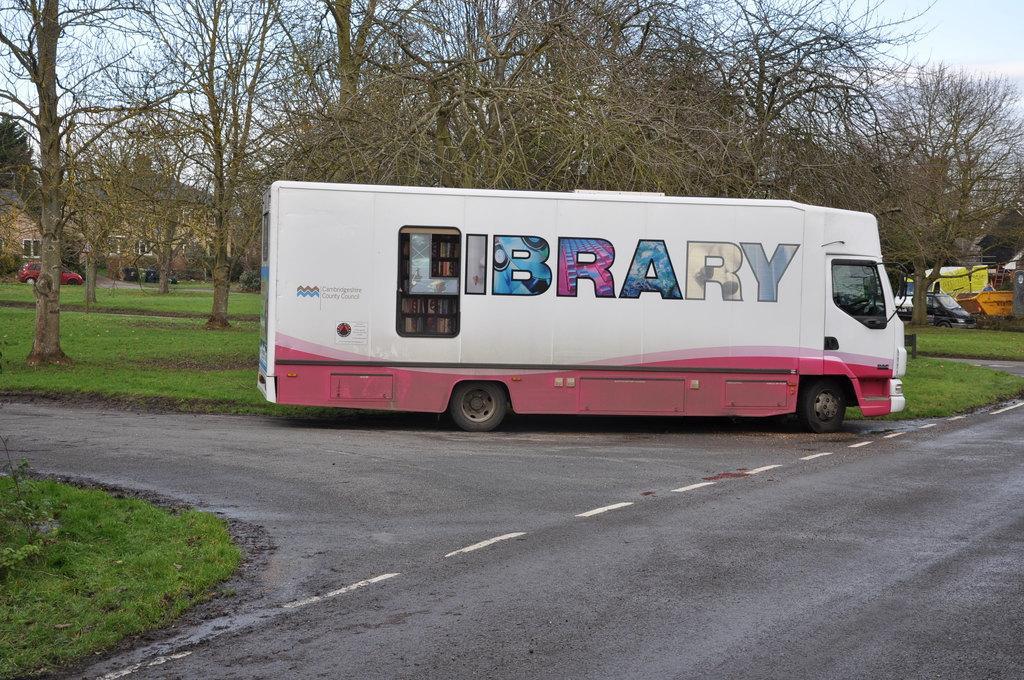Could you give a brief overview of what you see in this image? In the image we can see a vehicle on the road and on the vehicle we can see some text. Here we can see the road, grass and trees. There are even other vehicles of different colors and the sky. 